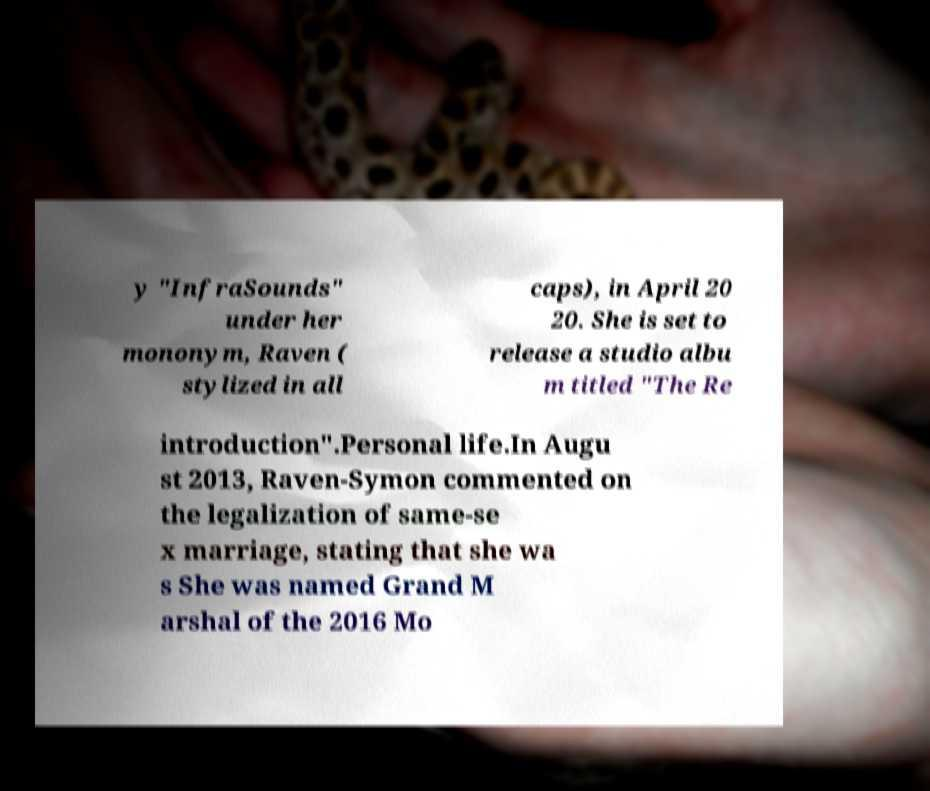There's text embedded in this image that I need extracted. Can you transcribe it verbatim? y "InfraSounds" under her mononym, Raven ( stylized in all caps), in April 20 20. She is set to release a studio albu m titled "The Re introduction".Personal life.In Augu st 2013, Raven-Symon commented on the legalization of same-se x marriage, stating that she wa s She was named Grand M arshal of the 2016 Mo 